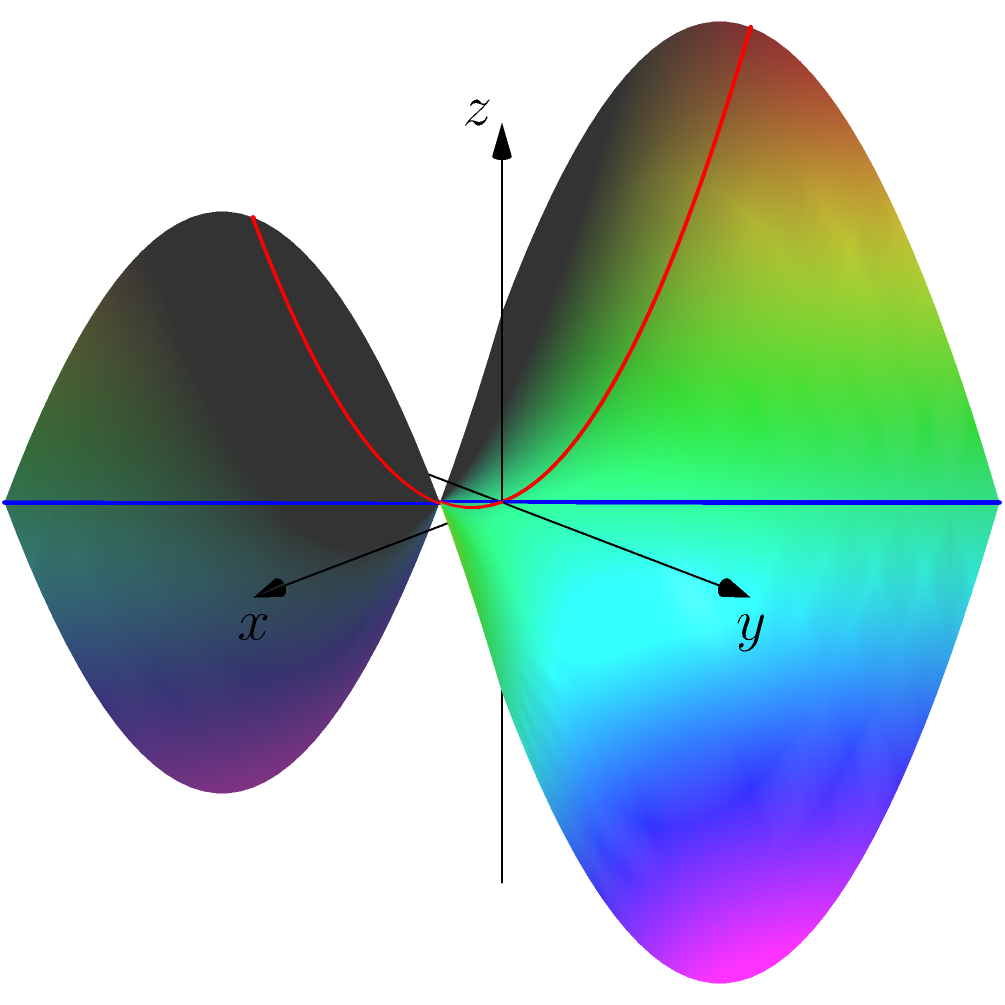As an event organizer, you're planning a unique geometry-themed party for your high school reunion. You want to create an immersive experience that showcases non-Euclidean geometry. In the image above, which represents a saddle-shaped surface, how would you describe the appearance of the blue and red lines to your classmates? To explain this to your classmates, you can follow these steps:

1. Identify the surface: The image shows a saddle-shaped surface, which is an example of a hyperbolic surface in non-Euclidean geometry.

2. Understand Euclidean vs. non-Euclidean geometry:
   - In Euclidean geometry (flat surfaces), straight lines are always the shortest distance between two points.
   - In non-Euclidean geometry, this isn't always true due to the curvature of the surface.

3. Observe the blue line:
   - It follows the contour of the saddle, curving downward on both sides.
   - This line represents a geodesic, which is the shortest path between two points on this curved surface.

4. Observe the red line:
   - It goes straight through the center of the saddle.
   - This line also represents a geodesic on this surface.

5. Compare the lines:
   - Both lines appear curved when viewed from our 3D perspective.
   - However, from the perspective of an inhabitant on the surface, these would be perceived as "straight" lines.

6. Explain the concept:
   - In non-Euclidean geometry, "straight" lines can appear curved when viewed from outside the surface.
   - These lines follow the most efficient path on the curved surface, similar to how airlines fly in arcs over a globe rather than in straight lines on a flat map.

7. Relate to the reunion theme:
   - This visualization demonstrates how our perception of "straightness" can change depending on the geometry of our space, just as our perspectives may have changed since high school.
Answer: The blue and red lines appear curved but represent "straight" paths (geodesics) on the saddle-shaped surface, demonstrating how non-Euclidean geometry differs from our usual flat-space intuition. 